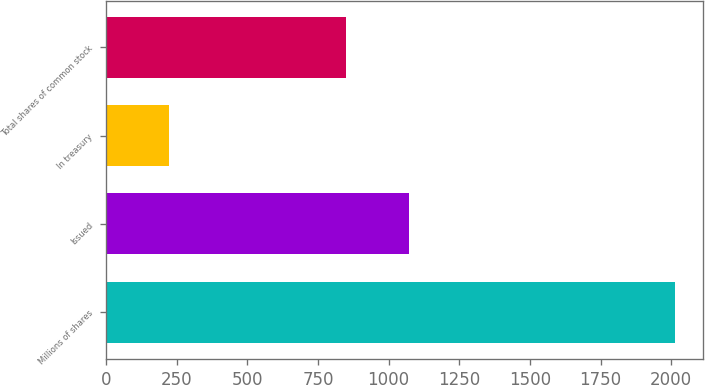Convert chart to OTSL. <chart><loc_0><loc_0><loc_500><loc_500><bar_chart><fcel>Millions of shares<fcel>Issued<fcel>In treasury<fcel>Total shares of common stock<nl><fcel>2013<fcel>1072<fcel>223<fcel>849<nl></chart> 